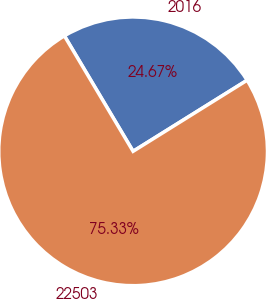Convert chart. <chart><loc_0><loc_0><loc_500><loc_500><pie_chart><fcel>2016<fcel>22503<nl><fcel>24.67%<fcel>75.33%<nl></chart> 